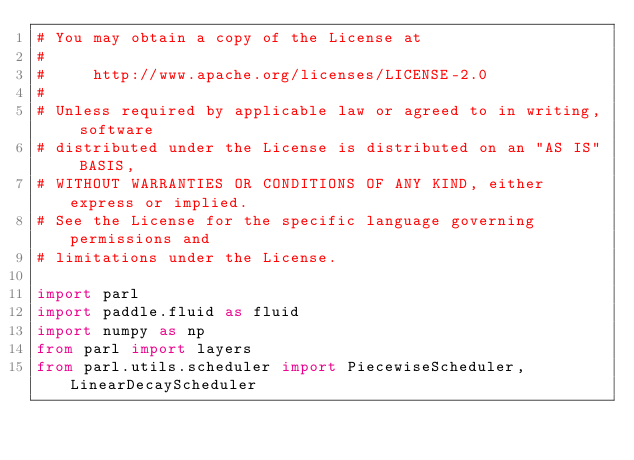<code> <loc_0><loc_0><loc_500><loc_500><_Python_># You may obtain a copy of the License at
#
#     http://www.apache.org/licenses/LICENSE-2.0
#
# Unless required by applicable law or agreed to in writing, software
# distributed under the License is distributed on an "AS IS" BASIS,
# WITHOUT WARRANTIES OR CONDITIONS OF ANY KIND, either express or implied.
# See the License for the specific language governing permissions and
# limitations under the License.

import parl
import paddle.fluid as fluid
import numpy as np
from parl import layers
from parl.utils.scheduler import PiecewiseScheduler, LinearDecayScheduler

</code> 